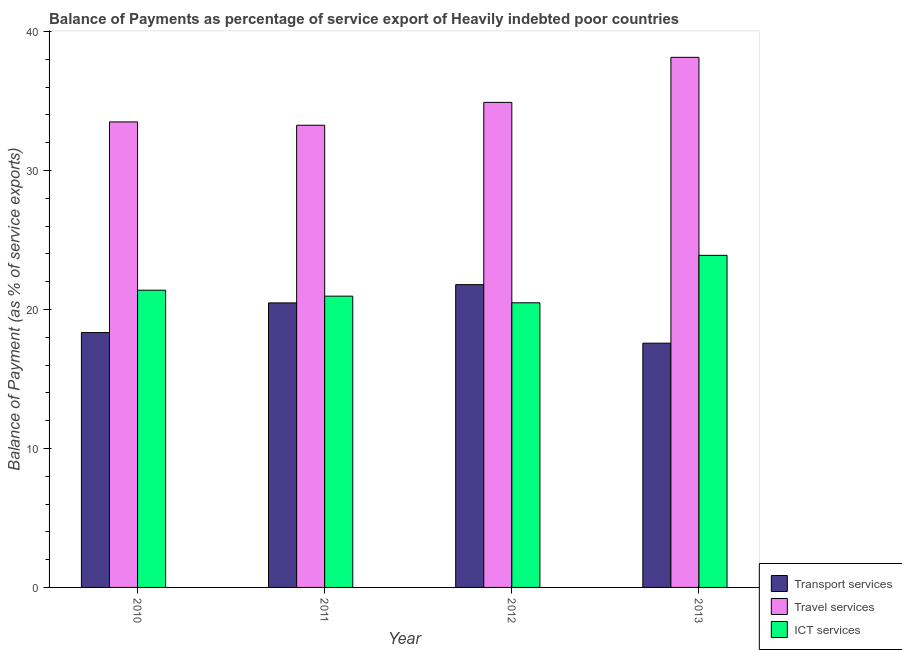Are the number of bars on each tick of the X-axis equal?
Your response must be concise. Yes. How many bars are there on the 4th tick from the right?
Provide a succinct answer. 3. What is the balance of payment of ict services in 2010?
Your response must be concise. 21.39. Across all years, what is the maximum balance of payment of transport services?
Offer a very short reply. 21.79. Across all years, what is the minimum balance of payment of travel services?
Make the answer very short. 33.26. In which year was the balance of payment of travel services maximum?
Provide a succinct answer. 2013. What is the total balance of payment of travel services in the graph?
Offer a terse response. 139.81. What is the difference between the balance of payment of ict services in 2010 and that in 2011?
Your answer should be very brief. 0.43. What is the difference between the balance of payment of travel services in 2011 and the balance of payment of ict services in 2012?
Your response must be concise. -1.65. What is the average balance of payment of travel services per year?
Keep it short and to the point. 34.95. What is the ratio of the balance of payment of travel services in 2011 to that in 2013?
Your response must be concise. 0.87. Is the balance of payment of ict services in 2010 less than that in 2011?
Offer a terse response. No. Is the difference between the balance of payment of transport services in 2010 and 2011 greater than the difference between the balance of payment of ict services in 2010 and 2011?
Your answer should be compact. No. What is the difference between the highest and the second highest balance of payment of travel services?
Your answer should be compact. 3.24. What is the difference between the highest and the lowest balance of payment of transport services?
Provide a short and direct response. 4.21. What does the 1st bar from the left in 2012 represents?
Your answer should be very brief. Transport services. What does the 1st bar from the right in 2011 represents?
Ensure brevity in your answer.  ICT services. How many bars are there?
Your response must be concise. 12. How many years are there in the graph?
Offer a very short reply. 4. What is the difference between two consecutive major ticks on the Y-axis?
Your response must be concise. 10. Does the graph contain any zero values?
Provide a short and direct response. No. Does the graph contain grids?
Keep it short and to the point. No. Where does the legend appear in the graph?
Give a very brief answer. Bottom right. What is the title of the graph?
Offer a very short reply. Balance of Payments as percentage of service export of Heavily indebted poor countries. What is the label or title of the Y-axis?
Your answer should be very brief. Balance of Payment (as % of service exports). What is the Balance of Payment (as % of service exports) in Transport services in 2010?
Offer a terse response. 18.34. What is the Balance of Payment (as % of service exports) in Travel services in 2010?
Your response must be concise. 33.5. What is the Balance of Payment (as % of service exports) in ICT services in 2010?
Your response must be concise. 21.39. What is the Balance of Payment (as % of service exports) of Transport services in 2011?
Your response must be concise. 20.48. What is the Balance of Payment (as % of service exports) of Travel services in 2011?
Provide a succinct answer. 33.26. What is the Balance of Payment (as % of service exports) of ICT services in 2011?
Provide a succinct answer. 20.96. What is the Balance of Payment (as % of service exports) of Transport services in 2012?
Your answer should be compact. 21.79. What is the Balance of Payment (as % of service exports) in Travel services in 2012?
Your answer should be compact. 34.91. What is the Balance of Payment (as % of service exports) in ICT services in 2012?
Offer a terse response. 20.48. What is the Balance of Payment (as % of service exports) of Transport services in 2013?
Offer a very short reply. 17.58. What is the Balance of Payment (as % of service exports) in Travel services in 2013?
Offer a terse response. 38.15. What is the Balance of Payment (as % of service exports) of ICT services in 2013?
Your answer should be very brief. 23.9. Across all years, what is the maximum Balance of Payment (as % of service exports) in Transport services?
Make the answer very short. 21.79. Across all years, what is the maximum Balance of Payment (as % of service exports) in Travel services?
Your answer should be very brief. 38.15. Across all years, what is the maximum Balance of Payment (as % of service exports) of ICT services?
Offer a terse response. 23.9. Across all years, what is the minimum Balance of Payment (as % of service exports) in Transport services?
Ensure brevity in your answer.  17.58. Across all years, what is the minimum Balance of Payment (as % of service exports) of Travel services?
Your response must be concise. 33.26. Across all years, what is the minimum Balance of Payment (as % of service exports) of ICT services?
Make the answer very short. 20.48. What is the total Balance of Payment (as % of service exports) in Transport services in the graph?
Provide a short and direct response. 78.18. What is the total Balance of Payment (as % of service exports) in Travel services in the graph?
Ensure brevity in your answer.  139.81. What is the total Balance of Payment (as % of service exports) in ICT services in the graph?
Your response must be concise. 86.73. What is the difference between the Balance of Payment (as % of service exports) of Transport services in 2010 and that in 2011?
Keep it short and to the point. -2.14. What is the difference between the Balance of Payment (as % of service exports) in Travel services in 2010 and that in 2011?
Offer a terse response. 0.24. What is the difference between the Balance of Payment (as % of service exports) of ICT services in 2010 and that in 2011?
Offer a terse response. 0.43. What is the difference between the Balance of Payment (as % of service exports) in Transport services in 2010 and that in 2012?
Your answer should be very brief. -3.45. What is the difference between the Balance of Payment (as % of service exports) in Travel services in 2010 and that in 2012?
Make the answer very short. -1.41. What is the difference between the Balance of Payment (as % of service exports) of ICT services in 2010 and that in 2012?
Offer a very short reply. 0.91. What is the difference between the Balance of Payment (as % of service exports) of Transport services in 2010 and that in 2013?
Keep it short and to the point. 0.76. What is the difference between the Balance of Payment (as % of service exports) of Travel services in 2010 and that in 2013?
Provide a short and direct response. -4.65. What is the difference between the Balance of Payment (as % of service exports) in ICT services in 2010 and that in 2013?
Ensure brevity in your answer.  -2.51. What is the difference between the Balance of Payment (as % of service exports) in Transport services in 2011 and that in 2012?
Your answer should be very brief. -1.31. What is the difference between the Balance of Payment (as % of service exports) in Travel services in 2011 and that in 2012?
Offer a very short reply. -1.65. What is the difference between the Balance of Payment (as % of service exports) in ICT services in 2011 and that in 2012?
Offer a terse response. 0.48. What is the difference between the Balance of Payment (as % of service exports) of Transport services in 2011 and that in 2013?
Provide a short and direct response. 2.9. What is the difference between the Balance of Payment (as % of service exports) in Travel services in 2011 and that in 2013?
Your answer should be compact. -4.89. What is the difference between the Balance of Payment (as % of service exports) of ICT services in 2011 and that in 2013?
Your response must be concise. -2.94. What is the difference between the Balance of Payment (as % of service exports) in Transport services in 2012 and that in 2013?
Make the answer very short. 4.21. What is the difference between the Balance of Payment (as % of service exports) in Travel services in 2012 and that in 2013?
Provide a short and direct response. -3.24. What is the difference between the Balance of Payment (as % of service exports) in ICT services in 2012 and that in 2013?
Give a very brief answer. -3.42. What is the difference between the Balance of Payment (as % of service exports) in Transport services in 2010 and the Balance of Payment (as % of service exports) in Travel services in 2011?
Your response must be concise. -14.92. What is the difference between the Balance of Payment (as % of service exports) of Transport services in 2010 and the Balance of Payment (as % of service exports) of ICT services in 2011?
Offer a very short reply. -2.62. What is the difference between the Balance of Payment (as % of service exports) in Travel services in 2010 and the Balance of Payment (as % of service exports) in ICT services in 2011?
Provide a succinct answer. 12.54. What is the difference between the Balance of Payment (as % of service exports) of Transport services in 2010 and the Balance of Payment (as % of service exports) of Travel services in 2012?
Provide a short and direct response. -16.57. What is the difference between the Balance of Payment (as % of service exports) of Transport services in 2010 and the Balance of Payment (as % of service exports) of ICT services in 2012?
Your answer should be very brief. -2.14. What is the difference between the Balance of Payment (as % of service exports) in Travel services in 2010 and the Balance of Payment (as % of service exports) in ICT services in 2012?
Ensure brevity in your answer.  13.02. What is the difference between the Balance of Payment (as % of service exports) of Transport services in 2010 and the Balance of Payment (as % of service exports) of Travel services in 2013?
Your answer should be compact. -19.81. What is the difference between the Balance of Payment (as % of service exports) in Transport services in 2010 and the Balance of Payment (as % of service exports) in ICT services in 2013?
Your answer should be compact. -5.56. What is the difference between the Balance of Payment (as % of service exports) of Travel services in 2010 and the Balance of Payment (as % of service exports) of ICT services in 2013?
Offer a very short reply. 9.6. What is the difference between the Balance of Payment (as % of service exports) of Transport services in 2011 and the Balance of Payment (as % of service exports) of Travel services in 2012?
Your answer should be very brief. -14.43. What is the difference between the Balance of Payment (as % of service exports) of Transport services in 2011 and the Balance of Payment (as % of service exports) of ICT services in 2012?
Your answer should be very brief. -0.01. What is the difference between the Balance of Payment (as % of service exports) in Travel services in 2011 and the Balance of Payment (as % of service exports) in ICT services in 2012?
Offer a very short reply. 12.78. What is the difference between the Balance of Payment (as % of service exports) in Transport services in 2011 and the Balance of Payment (as % of service exports) in Travel services in 2013?
Your response must be concise. -17.67. What is the difference between the Balance of Payment (as % of service exports) of Transport services in 2011 and the Balance of Payment (as % of service exports) of ICT services in 2013?
Keep it short and to the point. -3.42. What is the difference between the Balance of Payment (as % of service exports) of Travel services in 2011 and the Balance of Payment (as % of service exports) of ICT services in 2013?
Give a very brief answer. 9.36. What is the difference between the Balance of Payment (as % of service exports) in Transport services in 2012 and the Balance of Payment (as % of service exports) in Travel services in 2013?
Your answer should be very brief. -16.36. What is the difference between the Balance of Payment (as % of service exports) in Transport services in 2012 and the Balance of Payment (as % of service exports) in ICT services in 2013?
Your response must be concise. -2.11. What is the difference between the Balance of Payment (as % of service exports) of Travel services in 2012 and the Balance of Payment (as % of service exports) of ICT services in 2013?
Make the answer very short. 11.01. What is the average Balance of Payment (as % of service exports) in Transport services per year?
Ensure brevity in your answer.  19.55. What is the average Balance of Payment (as % of service exports) of Travel services per year?
Your answer should be compact. 34.95. What is the average Balance of Payment (as % of service exports) in ICT services per year?
Your response must be concise. 21.68. In the year 2010, what is the difference between the Balance of Payment (as % of service exports) in Transport services and Balance of Payment (as % of service exports) in Travel services?
Make the answer very short. -15.16. In the year 2010, what is the difference between the Balance of Payment (as % of service exports) of Transport services and Balance of Payment (as % of service exports) of ICT services?
Provide a succinct answer. -3.05. In the year 2010, what is the difference between the Balance of Payment (as % of service exports) of Travel services and Balance of Payment (as % of service exports) of ICT services?
Ensure brevity in your answer.  12.11. In the year 2011, what is the difference between the Balance of Payment (as % of service exports) of Transport services and Balance of Payment (as % of service exports) of Travel services?
Keep it short and to the point. -12.78. In the year 2011, what is the difference between the Balance of Payment (as % of service exports) of Transport services and Balance of Payment (as % of service exports) of ICT services?
Your answer should be very brief. -0.49. In the year 2011, what is the difference between the Balance of Payment (as % of service exports) in Travel services and Balance of Payment (as % of service exports) in ICT services?
Provide a short and direct response. 12.3. In the year 2012, what is the difference between the Balance of Payment (as % of service exports) in Transport services and Balance of Payment (as % of service exports) in Travel services?
Offer a very short reply. -13.11. In the year 2012, what is the difference between the Balance of Payment (as % of service exports) in Transport services and Balance of Payment (as % of service exports) in ICT services?
Your answer should be very brief. 1.31. In the year 2012, what is the difference between the Balance of Payment (as % of service exports) in Travel services and Balance of Payment (as % of service exports) in ICT services?
Make the answer very short. 14.42. In the year 2013, what is the difference between the Balance of Payment (as % of service exports) in Transport services and Balance of Payment (as % of service exports) in Travel services?
Make the answer very short. -20.57. In the year 2013, what is the difference between the Balance of Payment (as % of service exports) of Transport services and Balance of Payment (as % of service exports) of ICT services?
Ensure brevity in your answer.  -6.32. In the year 2013, what is the difference between the Balance of Payment (as % of service exports) in Travel services and Balance of Payment (as % of service exports) in ICT services?
Give a very brief answer. 14.25. What is the ratio of the Balance of Payment (as % of service exports) of Transport services in 2010 to that in 2011?
Provide a succinct answer. 0.9. What is the ratio of the Balance of Payment (as % of service exports) of Travel services in 2010 to that in 2011?
Make the answer very short. 1.01. What is the ratio of the Balance of Payment (as % of service exports) of ICT services in 2010 to that in 2011?
Your answer should be very brief. 1.02. What is the ratio of the Balance of Payment (as % of service exports) in Transport services in 2010 to that in 2012?
Give a very brief answer. 0.84. What is the ratio of the Balance of Payment (as % of service exports) in Travel services in 2010 to that in 2012?
Offer a terse response. 0.96. What is the ratio of the Balance of Payment (as % of service exports) of ICT services in 2010 to that in 2012?
Your answer should be very brief. 1.04. What is the ratio of the Balance of Payment (as % of service exports) of Transport services in 2010 to that in 2013?
Ensure brevity in your answer.  1.04. What is the ratio of the Balance of Payment (as % of service exports) of Travel services in 2010 to that in 2013?
Your answer should be very brief. 0.88. What is the ratio of the Balance of Payment (as % of service exports) of ICT services in 2010 to that in 2013?
Ensure brevity in your answer.  0.9. What is the ratio of the Balance of Payment (as % of service exports) in Transport services in 2011 to that in 2012?
Your response must be concise. 0.94. What is the ratio of the Balance of Payment (as % of service exports) in Travel services in 2011 to that in 2012?
Offer a terse response. 0.95. What is the ratio of the Balance of Payment (as % of service exports) of ICT services in 2011 to that in 2012?
Keep it short and to the point. 1.02. What is the ratio of the Balance of Payment (as % of service exports) of Transport services in 2011 to that in 2013?
Your answer should be very brief. 1.16. What is the ratio of the Balance of Payment (as % of service exports) in Travel services in 2011 to that in 2013?
Offer a very short reply. 0.87. What is the ratio of the Balance of Payment (as % of service exports) of ICT services in 2011 to that in 2013?
Your response must be concise. 0.88. What is the ratio of the Balance of Payment (as % of service exports) in Transport services in 2012 to that in 2013?
Offer a very short reply. 1.24. What is the ratio of the Balance of Payment (as % of service exports) of Travel services in 2012 to that in 2013?
Offer a very short reply. 0.92. What is the difference between the highest and the second highest Balance of Payment (as % of service exports) of Transport services?
Keep it short and to the point. 1.31. What is the difference between the highest and the second highest Balance of Payment (as % of service exports) in Travel services?
Keep it short and to the point. 3.24. What is the difference between the highest and the second highest Balance of Payment (as % of service exports) of ICT services?
Give a very brief answer. 2.51. What is the difference between the highest and the lowest Balance of Payment (as % of service exports) in Transport services?
Make the answer very short. 4.21. What is the difference between the highest and the lowest Balance of Payment (as % of service exports) in Travel services?
Ensure brevity in your answer.  4.89. What is the difference between the highest and the lowest Balance of Payment (as % of service exports) in ICT services?
Your answer should be very brief. 3.42. 